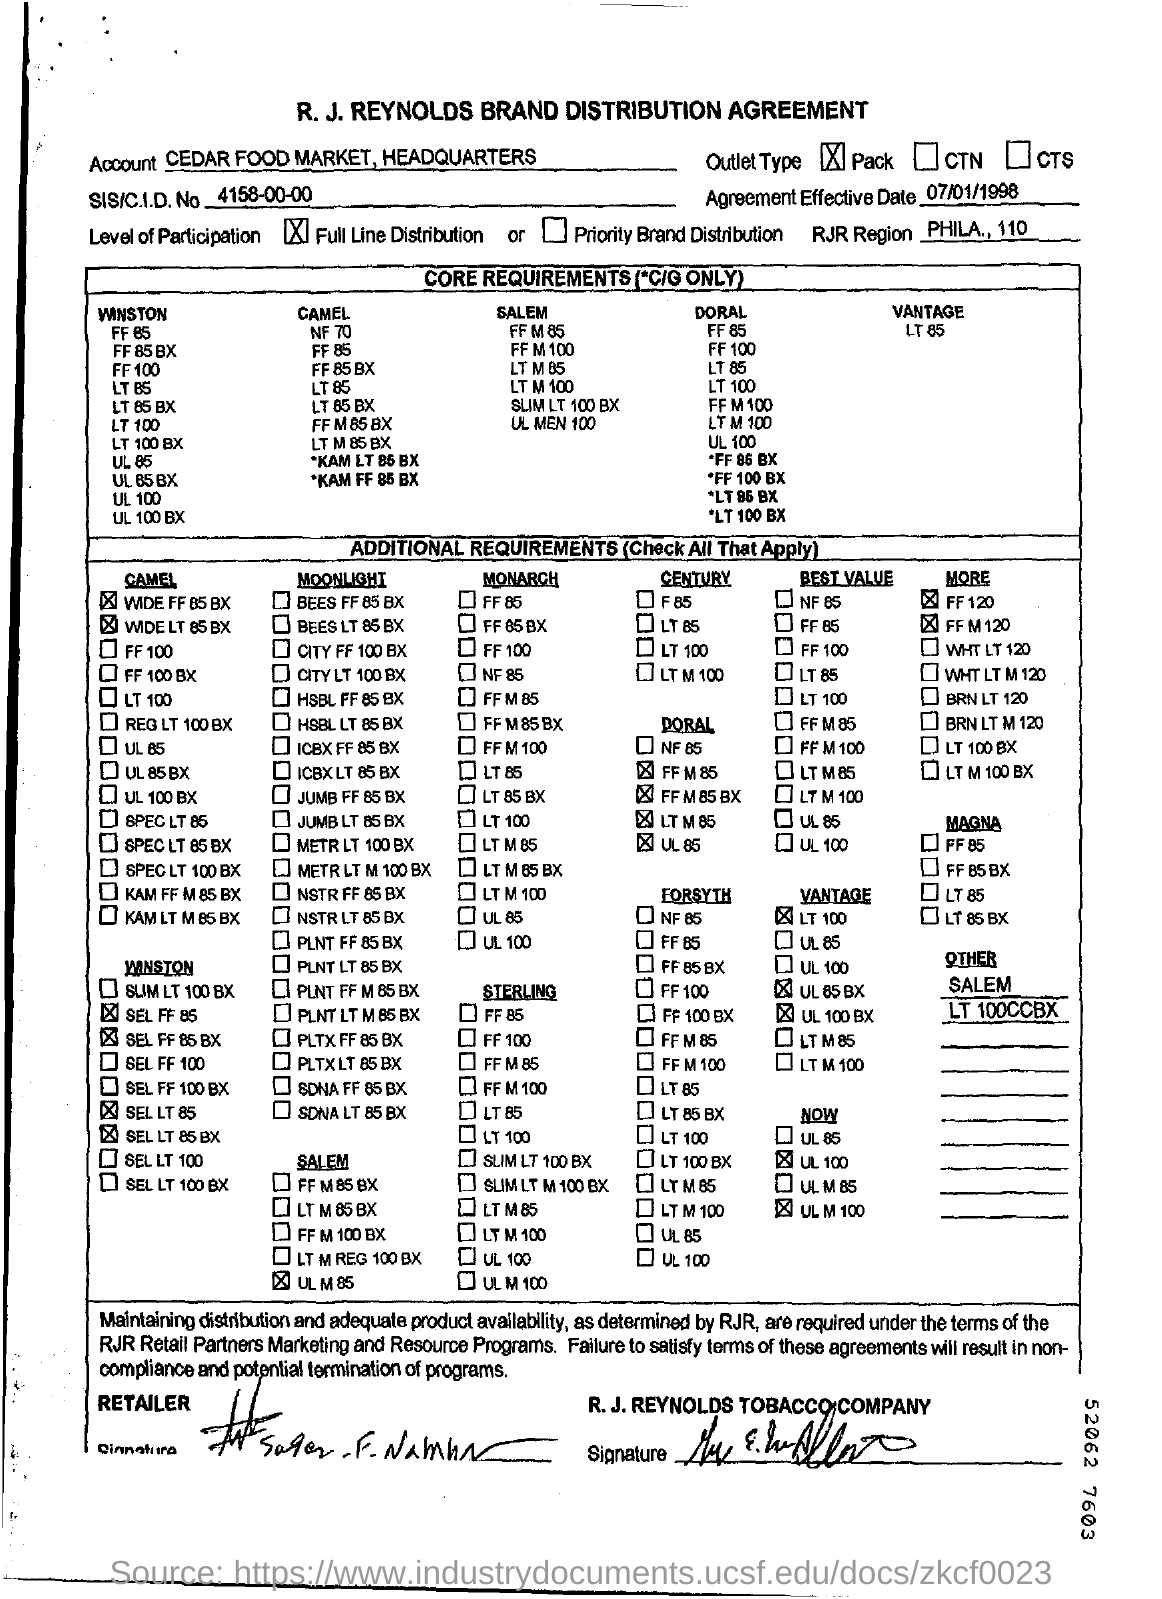What is the title of this document?
Provide a succinct answer. R. J. REYNOLDS BRAND DISTRIBUTION AGREEMENT. What is the account name mentioned?
Offer a very short reply. CEDAR FOOD MARKET. What is the outlet type
Keep it short and to the point. Pack. What is SIS/CID no?
Give a very brief answer. 4158-00-00. What is the effective date of agreement?
Offer a very short reply. 07/01/1998. What is Level of participation?
Offer a very short reply. Full line Distribution. 